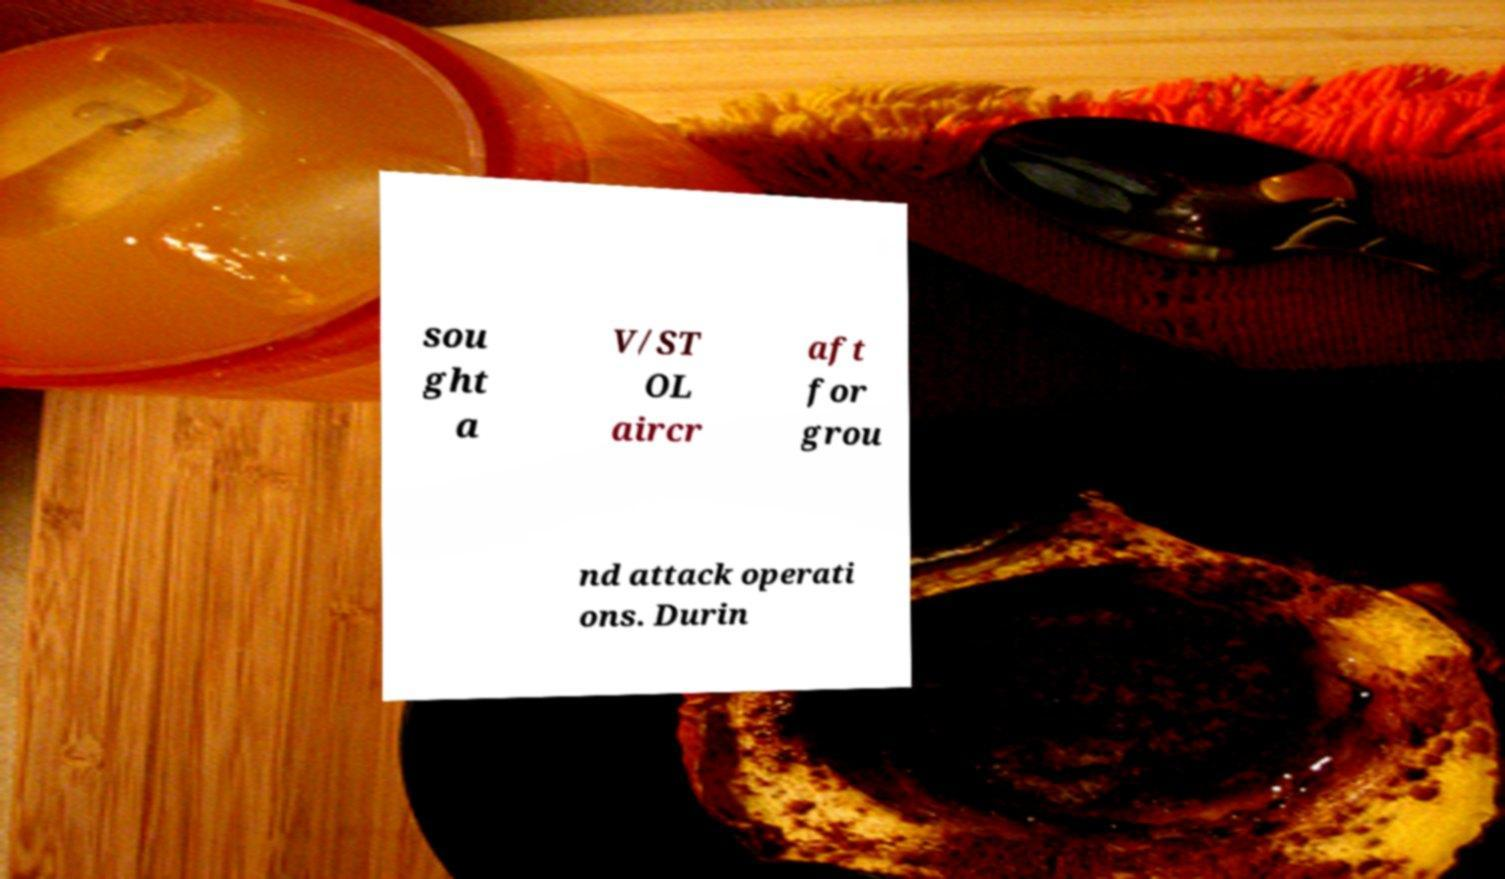What messages or text are displayed in this image? I need them in a readable, typed format. sou ght a V/ST OL aircr aft for grou nd attack operati ons. Durin 